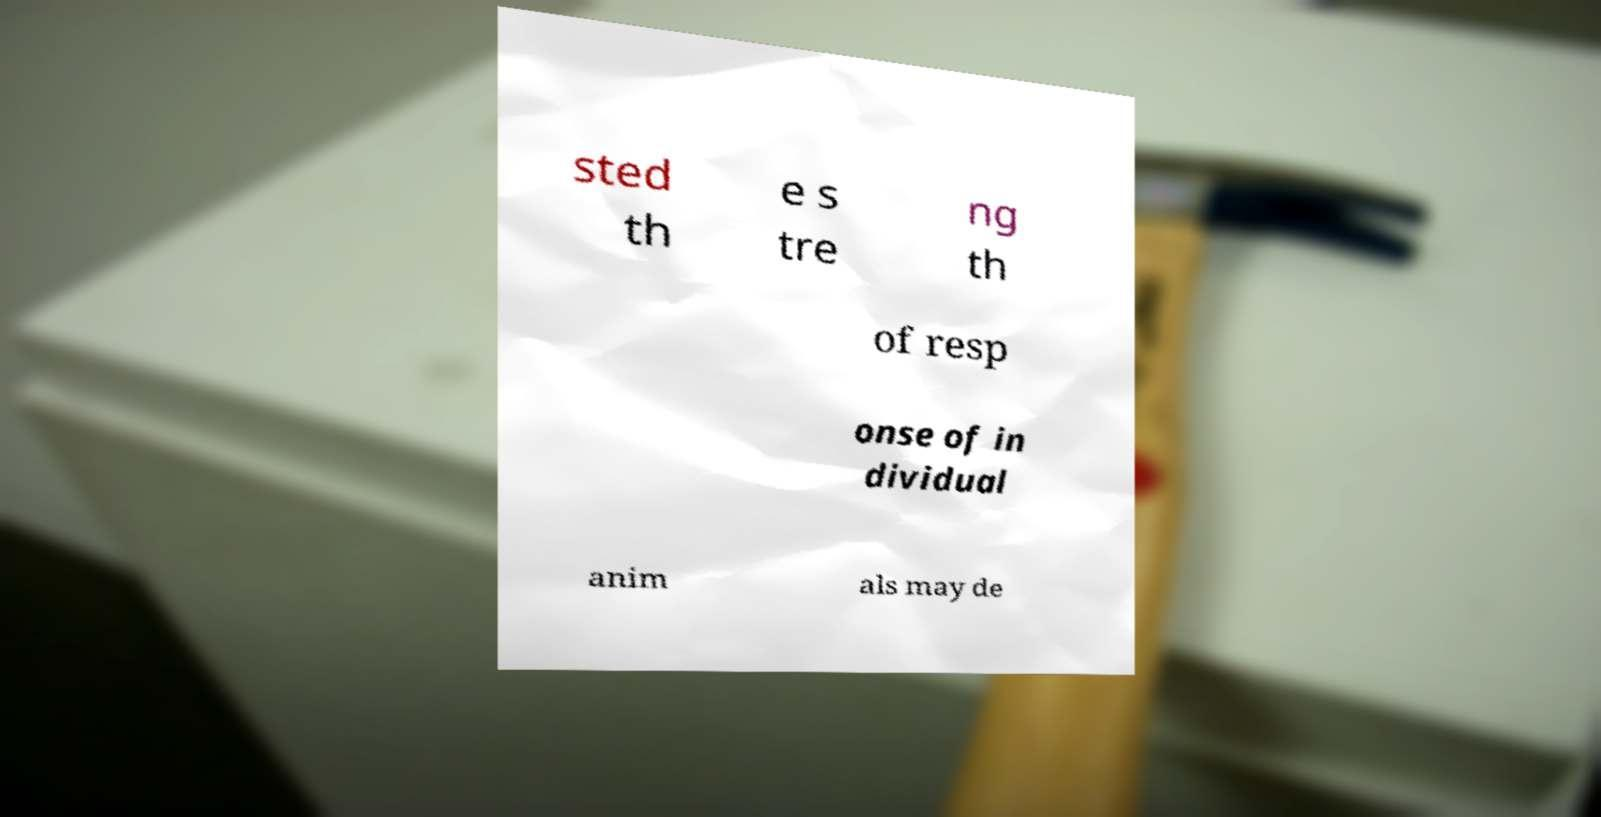Please read and relay the text visible in this image. What does it say? sted th e s tre ng th of resp onse of in dividual anim als may de 